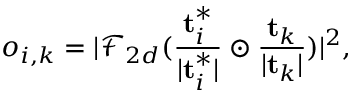<formula> <loc_0><loc_0><loc_500><loc_500>o _ { i , k } = | \mathcal { F } _ { 2 d } ( \frac { t _ { i } ^ { * } } { | t _ { i } ^ { * } | } \odot \frac { t _ { k } } { | t _ { k } | } ) | ^ { 2 } ,</formula> 